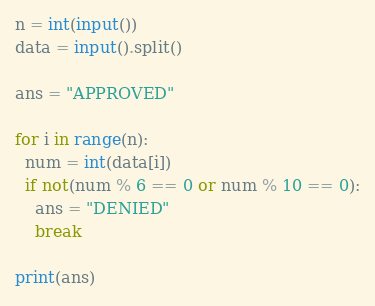Convert code to text. <code><loc_0><loc_0><loc_500><loc_500><_Python_>n = int(input())
data = input().split()
 
ans = "APPROVED"
 
for i in range(n):
  num = int(data[i])
  if not(num % 6 == 0 or num % 10 == 0):
    ans = "DENIED"
    break
 
print(ans)
</code> 